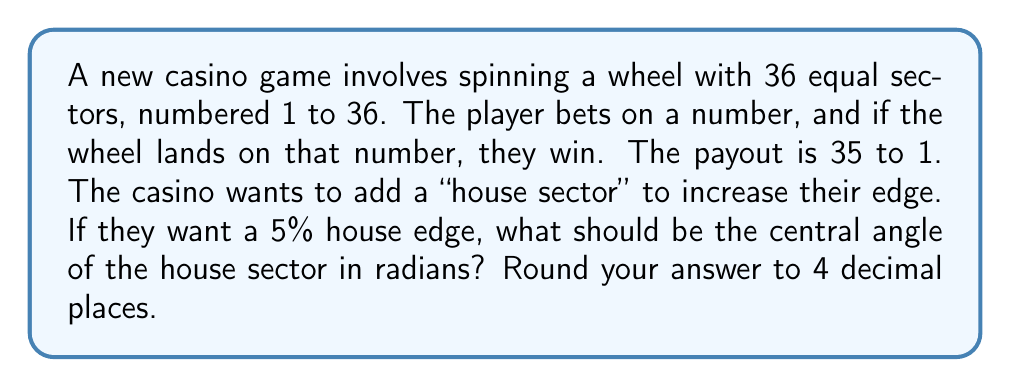Show me your answer to this math problem. Let's approach this step-by-step:

1) First, we need to understand what house edge means. It's the average profit the casino expects to make from each bet placed by the player.

2) In a fair game with 36 sectors, the probability of winning would be $\frac{1}{36}$, and with a 35 to 1 payout, the expected value for the player would be:

   $E = \frac{1}{36} \cdot 35 - \frac{35}{36} \cdot 1 = 0$

3) To create a 5% house edge, we need to add a house sector that makes the expected value for the player -5% of their bet. Let $x$ be the probability of landing on the house sector.

4) The new expected value equation would be:

   $E = (1-x) \cdot (\frac{1}{36} \cdot 35 - \frac{35}{36} \cdot 1) - x = -0.05$

5) Simplifying:

   $-x = -0.05$
   $x = 0.05$

6) So, the probability of landing on the house sector should be 0.05 or 5%.

7) Now, we need to find the central angle that corresponds to this probability. In a circle, probability is proportional to angle. The total angle is $2\pi$ radians.

8) Let $\theta$ be the central angle of the house sector in radians. Then:

   $\frac{\theta}{2\pi} = 0.05$

9) Solving for $\theta$:

   $\theta = 0.05 \cdot 2\pi = 0.1\pi \approx 0.3142$ radians

10) Rounding to 4 decimal places: 0.3142 radians.
Answer: 0.3142 radians 